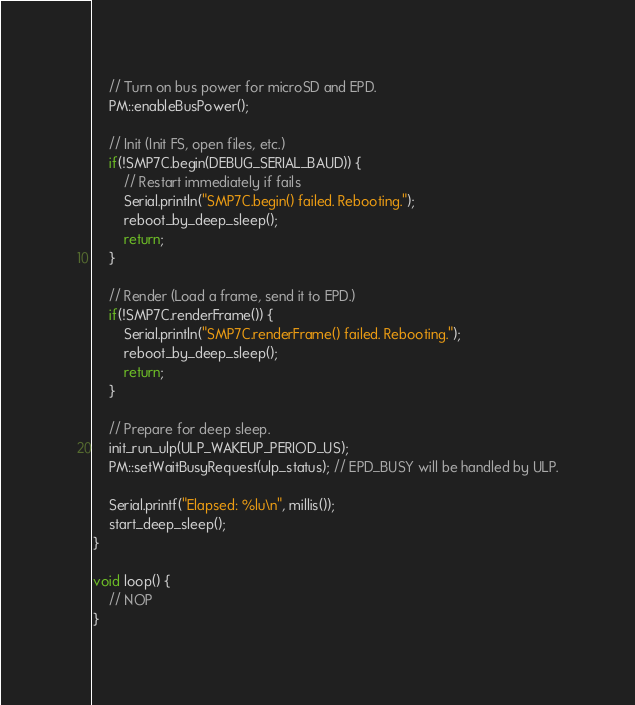<code> <loc_0><loc_0><loc_500><loc_500><_C++_>    // Turn on bus power for microSD and EPD.
    PM::enableBusPower();

    // Init (Init FS, open files, etc.)
    if(!SMP7C.begin(DEBUG_SERIAL_BAUD)) {
        // Restart immediately if fails
        Serial.println("SMP7C.begin() failed. Rebooting.");
        reboot_by_deep_sleep();
        return;
    }

    // Render (Load a frame, send it to EPD.)
    if(!SMP7C.renderFrame()) {
        Serial.println("SMP7C.renderFrame() failed. Rebooting.");
        reboot_by_deep_sleep();
        return;
    }

    // Prepare for deep sleep.
    init_run_ulp(ULP_WAKEUP_PERIOD_US);
    PM::setWaitBusyRequest(ulp_status); // EPD_BUSY will be handled by ULP.

    Serial.printf("Elapsed: %lu\n", millis());
    start_deep_sleep();
}

void loop() {
    // NOP
}
</code> 